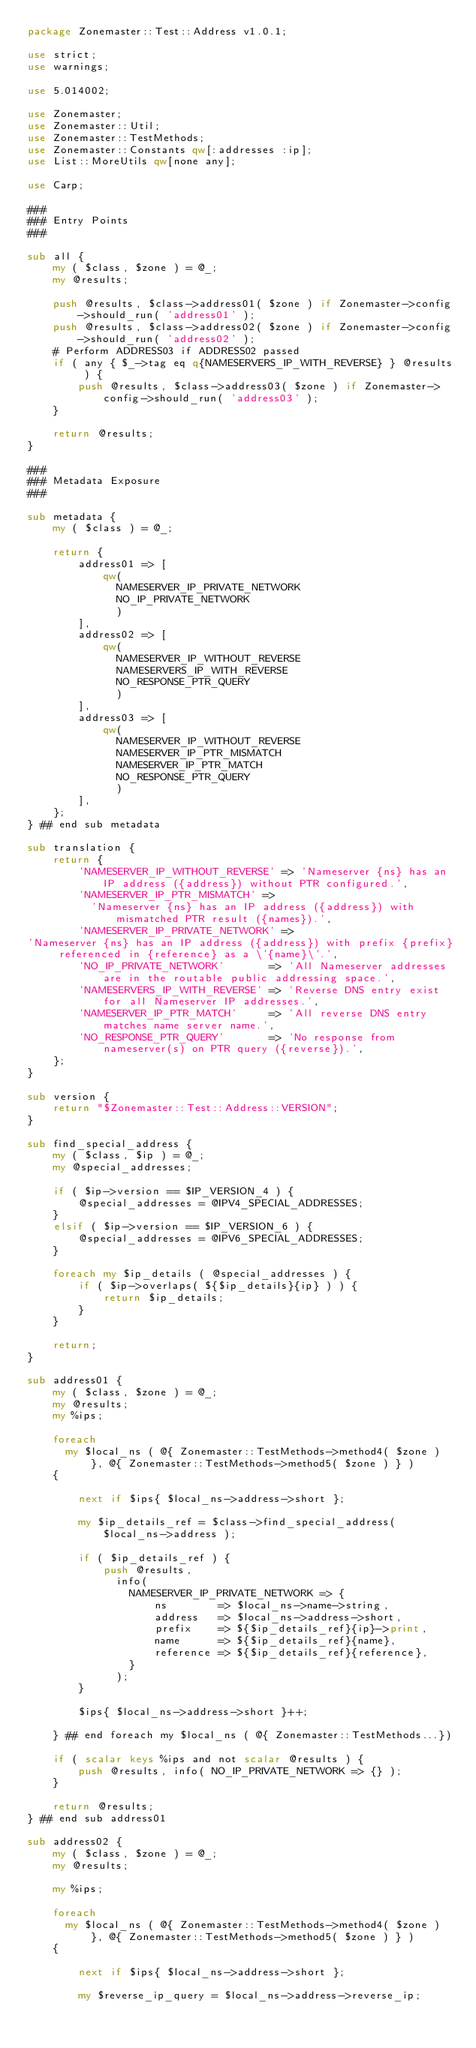<code> <loc_0><loc_0><loc_500><loc_500><_Perl_>package Zonemaster::Test::Address v1.0.1;

use strict;
use warnings;

use 5.014002;

use Zonemaster;
use Zonemaster::Util;
use Zonemaster::TestMethods;
use Zonemaster::Constants qw[:addresses :ip];
use List::MoreUtils qw[none any];

use Carp;

###
### Entry Points
###

sub all {
    my ( $class, $zone ) = @_;
    my @results;

    push @results, $class->address01( $zone ) if Zonemaster->config->should_run( 'address01' );
    push @results, $class->address02( $zone ) if Zonemaster->config->should_run( 'address02' );
    # Perform ADDRESS03 if ADDRESS02 passed
    if ( any { $_->tag eq q{NAMESERVERS_IP_WITH_REVERSE} } @results ) {
        push @results, $class->address03( $zone ) if Zonemaster->config->should_run( 'address03' );
    }

    return @results;
}

###
### Metadata Exposure
###

sub metadata {
    my ( $class ) = @_;

    return {
        address01 => [
            qw(
              NAMESERVER_IP_PRIVATE_NETWORK
              NO_IP_PRIVATE_NETWORK
              )
        ],
        address02 => [
            qw(
              NAMESERVER_IP_WITHOUT_REVERSE
              NAMESERVERS_IP_WITH_REVERSE
              NO_RESPONSE_PTR_QUERY
              )
        ],
        address03 => [
            qw(
              NAMESERVER_IP_WITHOUT_REVERSE
              NAMESERVER_IP_PTR_MISMATCH
              NAMESERVER_IP_PTR_MATCH
              NO_RESPONSE_PTR_QUERY
              )
        ],
    };
} ## end sub metadata

sub translation {
    return {
        'NAMESERVER_IP_WITHOUT_REVERSE' => 'Nameserver {ns} has an IP address ({address}) without PTR configured.',
        'NAMESERVER_IP_PTR_MISMATCH' =>
          'Nameserver {ns} has an IP address ({address}) with mismatched PTR result ({names}).',
        'NAMESERVER_IP_PRIVATE_NETWORK' =>
'Nameserver {ns} has an IP address ({address}) with prefix {prefix} referenced in {reference} as a \'{name}\'.',
        'NO_IP_PRIVATE_NETWORK'       => 'All Nameserver addresses are in the routable public addressing space.',
        'NAMESERVERS_IP_WITH_REVERSE' => 'Reverse DNS entry exist for all Nameserver IP addresses.',
        'NAMESERVER_IP_PTR_MATCH'     => 'All reverse DNS entry matches name server name.',
        'NO_RESPONSE_PTR_QUERY'       => 'No response from nameserver(s) on PTR query ({reverse}).',
    };
}

sub version {
    return "$Zonemaster::Test::Address::VERSION";
}

sub find_special_address {
    my ( $class, $ip ) = @_;
    my @special_addresses;

    if ( $ip->version == $IP_VERSION_4 ) {
        @special_addresses = @IPV4_SPECIAL_ADDRESSES;
    }
    elsif ( $ip->version == $IP_VERSION_6 ) {
        @special_addresses = @IPV6_SPECIAL_ADDRESSES;
    }

    foreach my $ip_details ( @special_addresses ) {
        if ( $ip->overlaps( ${$ip_details}{ip} ) ) {
            return $ip_details;
        }
    }

    return;
}

sub address01 {
    my ( $class, $zone ) = @_;
    my @results;
    my %ips;

    foreach
      my $local_ns ( @{ Zonemaster::TestMethods->method4( $zone ) }, @{ Zonemaster::TestMethods->method5( $zone ) } )
    {

        next if $ips{ $local_ns->address->short };

        my $ip_details_ref = $class->find_special_address( $local_ns->address );

        if ( $ip_details_ref ) {
            push @results,
              info(
                NAMESERVER_IP_PRIVATE_NETWORK => {
                    ns        => $local_ns->name->string,
                    address   => $local_ns->address->short,
                    prefix    => ${$ip_details_ref}{ip}->print,
                    name      => ${$ip_details_ref}{name},
                    reference => ${$ip_details_ref}{reference},
                }
              );
        }

        $ips{ $local_ns->address->short }++;

    } ## end foreach my $local_ns ( @{ Zonemaster::TestMethods...})

    if ( scalar keys %ips and not scalar @results ) {
        push @results, info( NO_IP_PRIVATE_NETWORK => {} );
    }

    return @results;
} ## end sub address01

sub address02 {
    my ( $class, $zone ) = @_;
    my @results;

    my %ips;

    foreach
      my $local_ns ( @{ Zonemaster::TestMethods->method4( $zone ) }, @{ Zonemaster::TestMethods->method5( $zone ) } )
    {

        next if $ips{ $local_ns->address->short };

        my $reverse_ip_query = $local_ns->address->reverse_ip;
</code> 